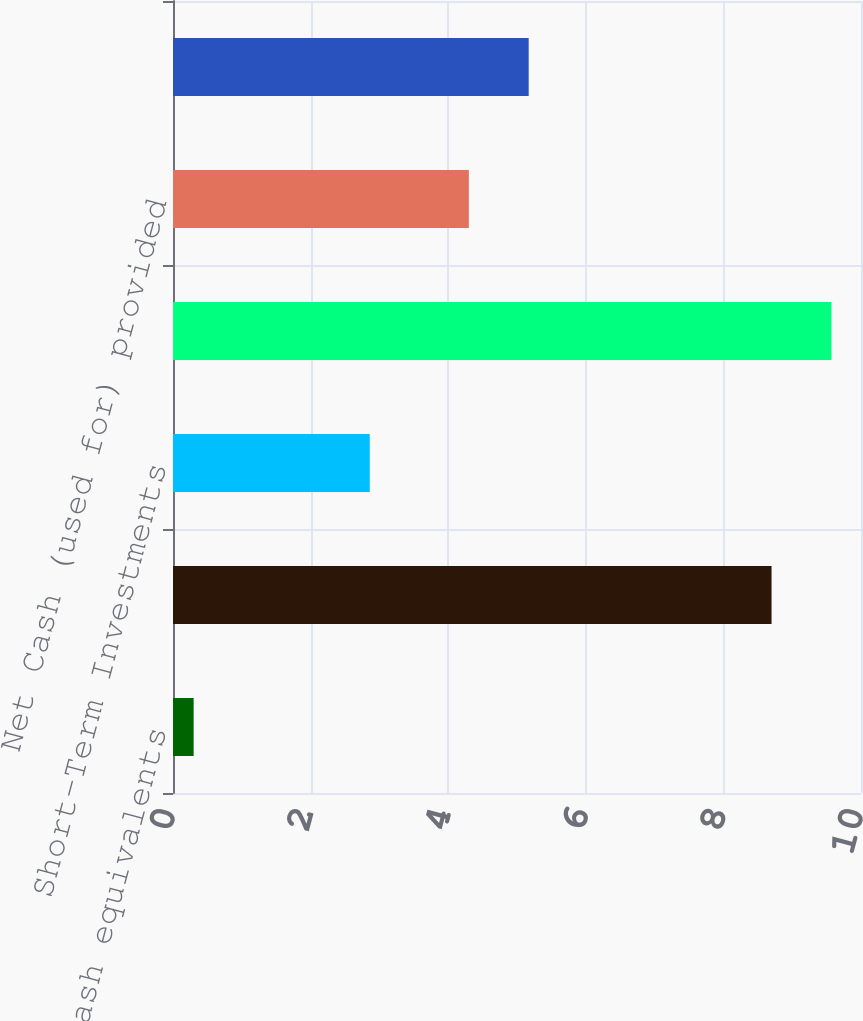<chart> <loc_0><loc_0><loc_500><loc_500><bar_chart><fcel>Cash and cash equivalents<fcel>Sigma Funds<fcel>Short-Term Investments<fcel>Total<fcel>Net Cash (used for) provided<fcel>Balance reflecting early 2007<nl><fcel>0.3<fcel>8.7<fcel>2.86<fcel>9.57<fcel>4.3<fcel>5.17<nl></chart> 